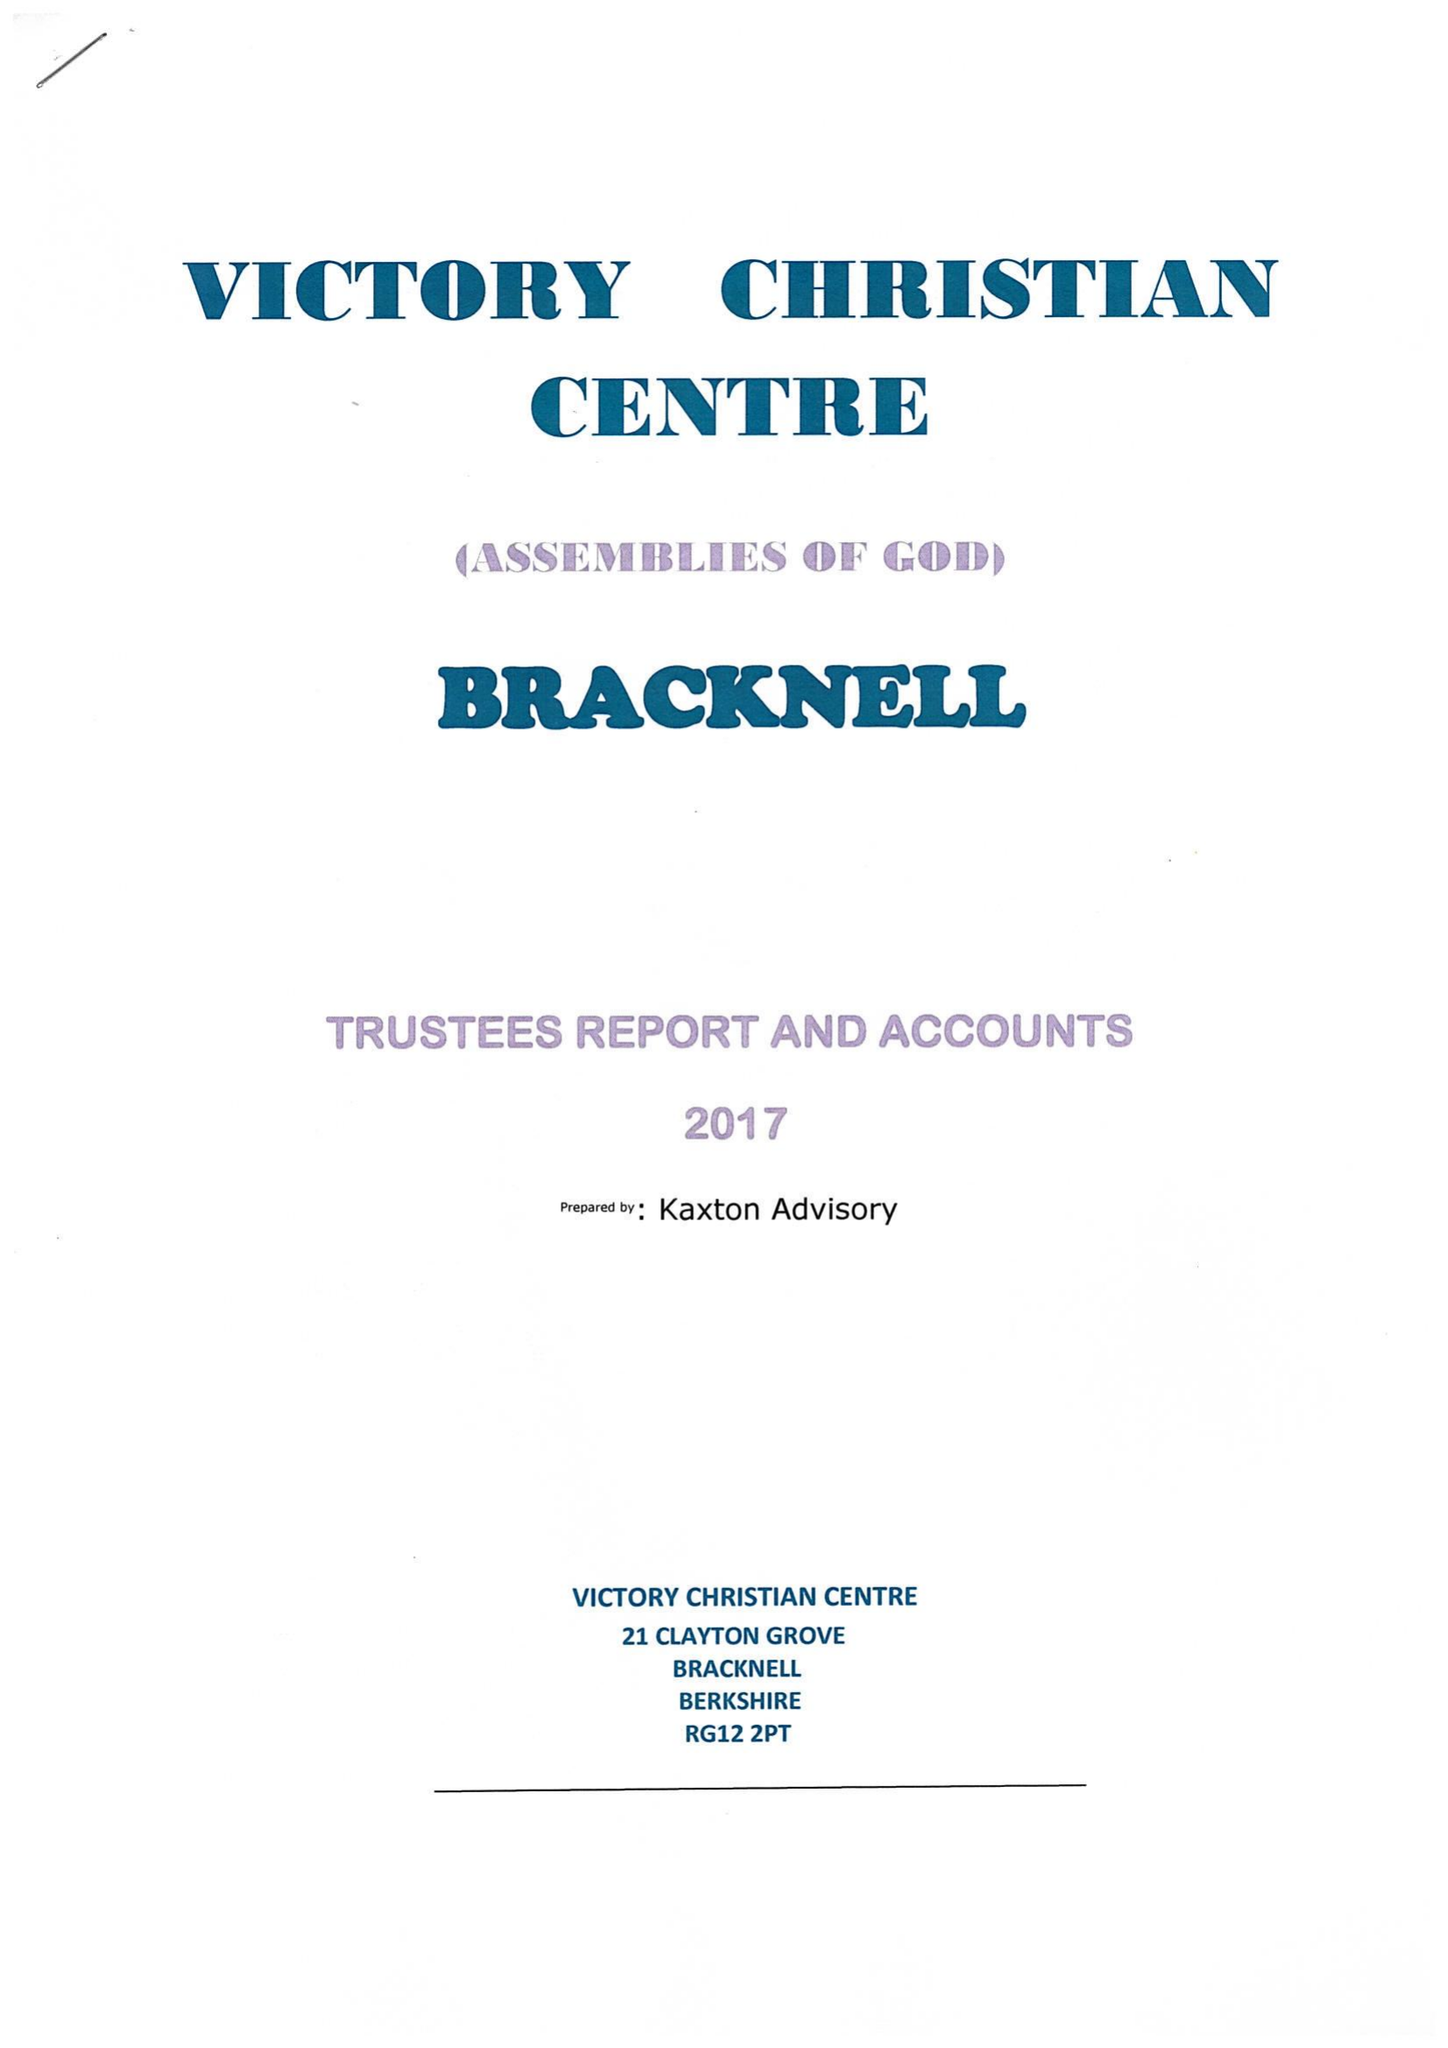What is the value for the address__postcode?
Answer the question using a single word or phrase. RG12 2PT 